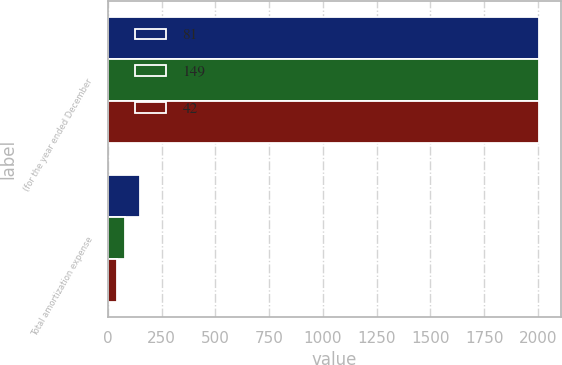<chart> <loc_0><loc_0><loc_500><loc_500><stacked_bar_chart><ecel><fcel>(for the year ended December<fcel>Total amortization expense<nl><fcel>81<fcel>2005<fcel>149<nl><fcel>149<fcel>2004<fcel>81<nl><fcel>42<fcel>2003<fcel>42<nl></chart> 